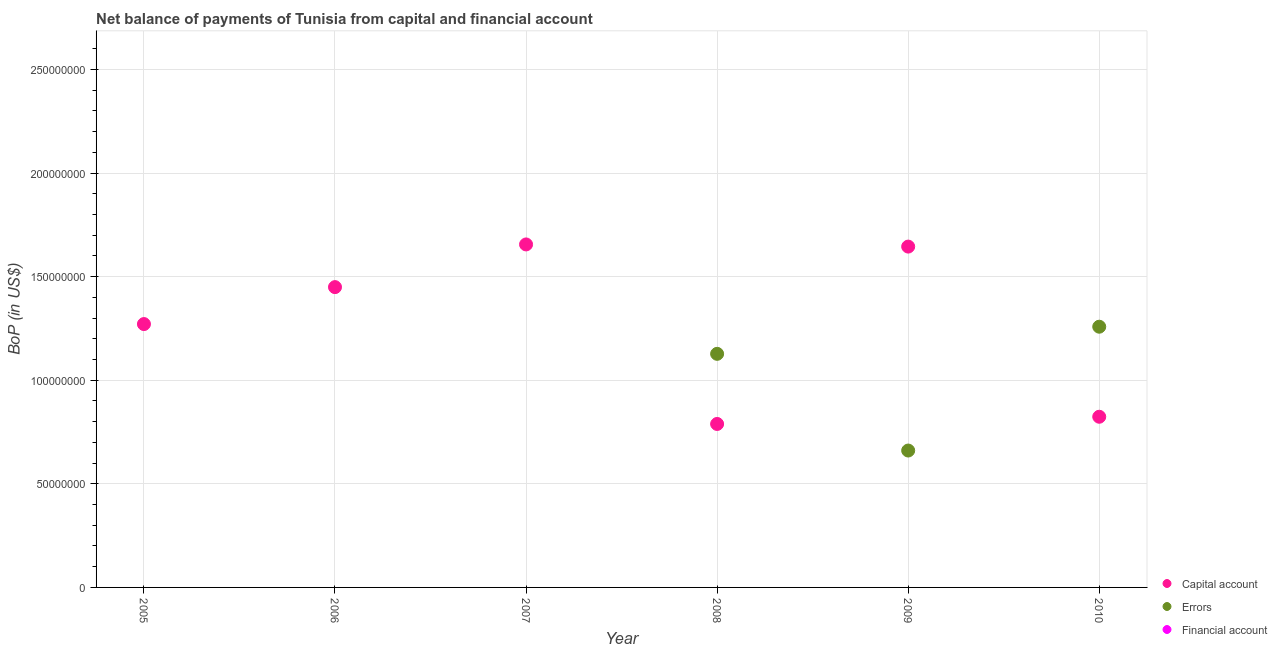What is the amount of net capital account in 2009?
Keep it short and to the point. 1.64e+08. Across all years, what is the maximum amount of errors?
Give a very brief answer. 1.26e+08. Across all years, what is the minimum amount of net capital account?
Ensure brevity in your answer.  7.89e+07. In which year was the amount of net capital account maximum?
Ensure brevity in your answer.  2007. What is the total amount of net capital account in the graph?
Your answer should be very brief. 7.63e+08. What is the difference between the amount of net capital account in 2008 and that in 2010?
Provide a succinct answer. -3.48e+06. What is the difference between the amount of financial account in 2009 and the amount of errors in 2008?
Your answer should be very brief. -1.13e+08. In the year 2010, what is the difference between the amount of errors and amount of net capital account?
Give a very brief answer. 4.35e+07. In how many years, is the amount of errors greater than 40000000 US$?
Provide a succinct answer. 3. What is the ratio of the amount of net capital account in 2006 to that in 2010?
Keep it short and to the point. 1.76. Is the amount of net capital account in 2005 less than that in 2010?
Make the answer very short. No. What is the difference between the highest and the second highest amount of net capital account?
Your response must be concise. 1.04e+06. What is the difference between the highest and the lowest amount of errors?
Your answer should be compact. 1.26e+08. Is the sum of the amount of net capital account in 2007 and 2009 greater than the maximum amount of errors across all years?
Make the answer very short. Yes. Is it the case that in every year, the sum of the amount of net capital account and amount of errors is greater than the amount of financial account?
Make the answer very short. Yes. Is the amount of net capital account strictly greater than the amount of errors over the years?
Keep it short and to the point. No. How many dotlines are there?
Ensure brevity in your answer.  2. Are the values on the major ticks of Y-axis written in scientific E-notation?
Your answer should be compact. No. Where does the legend appear in the graph?
Provide a succinct answer. Bottom right. What is the title of the graph?
Give a very brief answer. Net balance of payments of Tunisia from capital and financial account. Does "Ages 0-14" appear as one of the legend labels in the graph?
Give a very brief answer. No. What is the label or title of the X-axis?
Your answer should be compact. Year. What is the label or title of the Y-axis?
Your answer should be very brief. BoP (in US$). What is the BoP (in US$) of Capital account in 2005?
Make the answer very short. 1.27e+08. What is the BoP (in US$) of Financial account in 2005?
Provide a succinct answer. 0. What is the BoP (in US$) in Capital account in 2006?
Offer a terse response. 1.45e+08. What is the BoP (in US$) of Financial account in 2006?
Keep it short and to the point. 0. What is the BoP (in US$) in Capital account in 2007?
Provide a short and direct response. 1.66e+08. What is the BoP (in US$) of Errors in 2007?
Offer a very short reply. 0. What is the BoP (in US$) in Capital account in 2008?
Give a very brief answer. 7.89e+07. What is the BoP (in US$) in Errors in 2008?
Ensure brevity in your answer.  1.13e+08. What is the BoP (in US$) of Financial account in 2008?
Offer a very short reply. 0. What is the BoP (in US$) of Capital account in 2009?
Give a very brief answer. 1.64e+08. What is the BoP (in US$) of Errors in 2009?
Offer a very short reply. 6.61e+07. What is the BoP (in US$) in Financial account in 2009?
Offer a terse response. 0. What is the BoP (in US$) in Capital account in 2010?
Your response must be concise. 8.24e+07. What is the BoP (in US$) in Errors in 2010?
Keep it short and to the point. 1.26e+08. What is the BoP (in US$) of Financial account in 2010?
Give a very brief answer. 0. Across all years, what is the maximum BoP (in US$) of Capital account?
Give a very brief answer. 1.66e+08. Across all years, what is the maximum BoP (in US$) of Errors?
Your answer should be compact. 1.26e+08. Across all years, what is the minimum BoP (in US$) of Capital account?
Your response must be concise. 7.89e+07. What is the total BoP (in US$) in Capital account in the graph?
Keep it short and to the point. 7.63e+08. What is the total BoP (in US$) of Errors in the graph?
Offer a terse response. 3.05e+08. What is the difference between the BoP (in US$) in Capital account in 2005 and that in 2006?
Make the answer very short. -1.78e+07. What is the difference between the BoP (in US$) in Capital account in 2005 and that in 2007?
Ensure brevity in your answer.  -3.84e+07. What is the difference between the BoP (in US$) of Capital account in 2005 and that in 2008?
Ensure brevity in your answer.  4.82e+07. What is the difference between the BoP (in US$) in Capital account in 2005 and that in 2009?
Ensure brevity in your answer.  -3.74e+07. What is the difference between the BoP (in US$) in Capital account in 2005 and that in 2010?
Your answer should be compact. 4.47e+07. What is the difference between the BoP (in US$) of Capital account in 2006 and that in 2007?
Offer a terse response. -2.06e+07. What is the difference between the BoP (in US$) of Capital account in 2006 and that in 2008?
Give a very brief answer. 6.60e+07. What is the difference between the BoP (in US$) of Capital account in 2006 and that in 2009?
Your response must be concise. -1.96e+07. What is the difference between the BoP (in US$) of Capital account in 2006 and that in 2010?
Ensure brevity in your answer.  6.26e+07. What is the difference between the BoP (in US$) of Capital account in 2007 and that in 2008?
Provide a succinct answer. 8.66e+07. What is the difference between the BoP (in US$) of Capital account in 2007 and that in 2009?
Provide a succinct answer. 1.04e+06. What is the difference between the BoP (in US$) of Capital account in 2007 and that in 2010?
Provide a succinct answer. 8.32e+07. What is the difference between the BoP (in US$) in Capital account in 2008 and that in 2009?
Offer a very short reply. -8.56e+07. What is the difference between the BoP (in US$) in Errors in 2008 and that in 2009?
Make the answer very short. 4.67e+07. What is the difference between the BoP (in US$) of Capital account in 2008 and that in 2010?
Your answer should be very brief. -3.48e+06. What is the difference between the BoP (in US$) of Errors in 2008 and that in 2010?
Give a very brief answer. -1.31e+07. What is the difference between the BoP (in US$) of Capital account in 2009 and that in 2010?
Provide a short and direct response. 8.21e+07. What is the difference between the BoP (in US$) in Errors in 2009 and that in 2010?
Your answer should be very brief. -5.98e+07. What is the difference between the BoP (in US$) in Capital account in 2005 and the BoP (in US$) in Errors in 2008?
Your answer should be compact. 1.44e+07. What is the difference between the BoP (in US$) of Capital account in 2005 and the BoP (in US$) of Errors in 2009?
Your answer should be very brief. 6.10e+07. What is the difference between the BoP (in US$) of Capital account in 2005 and the BoP (in US$) of Errors in 2010?
Ensure brevity in your answer.  1.28e+06. What is the difference between the BoP (in US$) in Capital account in 2006 and the BoP (in US$) in Errors in 2008?
Offer a terse response. 3.22e+07. What is the difference between the BoP (in US$) in Capital account in 2006 and the BoP (in US$) in Errors in 2009?
Give a very brief answer. 7.89e+07. What is the difference between the BoP (in US$) of Capital account in 2006 and the BoP (in US$) of Errors in 2010?
Keep it short and to the point. 1.91e+07. What is the difference between the BoP (in US$) in Capital account in 2007 and the BoP (in US$) in Errors in 2008?
Your response must be concise. 5.28e+07. What is the difference between the BoP (in US$) of Capital account in 2007 and the BoP (in US$) of Errors in 2009?
Give a very brief answer. 9.95e+07. What is the difference between the BoP (in US$) in Capital account in 2007 and the BoP (in US$) in Errors in 2010?
Your answer should be very brief. 3.97e+07. What is the difference between the BoP (in US$) in Capital account in 2008 and the BoP (in US$) in Errors in 2009?
Provide a short and direct response. 1.28e+07. What is the difference between the BoP (in US$) of Capital account in 2008 and the BoP (in US$) of Errors in 2010?
Provide a succinct answer. -4.69e+07. What is the difference between the BoP (in US$) of Capital account in 2009 and the BoP (in US$) of Errors in 2010?
Keep it short and to the point. 3.87e+07. What is the average BoP (in US$) of Capital account per year?
Make the answer very short. 1.27e+08. What is the average BoP (in US$) in Errors per year?
Provide a succinct answer. 5.08e+07. In the year 2008, what is the difference between the BoP (in US$) in Capital account and BoP (in US$) in Errors?
Provide a succinct answer. -3.38e+07. In the year 2009, what is the difference between the BoP (in US$) in Capital account and BoP (in US$) in Errors?
Provide a short and direct response. 9.84e+07. In the year 2010, what is the difference between the BoP (in US$) in Capital account and BoP (in US$) in Errors?
Your answer should be compact. -4.35e+07. What is the ratio of the BoP (in US$) in Capital account in 2005 to that in 2006?
Offer a very short reply. 0.88. What is the ratio of the BoP (in US$) of Capital account in 2005 to that in 2007?
Offer a very short reply. 0.77. What is the ratio of the BoP (in US$) in Capital account in 2005 to that in 2008?
Give a very brief answer. 1.61. What is the ratio of the BoP (in US$) of Capital account in 2005 to that in 2009?
Keep it short and to the point. 0.77. What is the ratio of the BoP (in US$) in Capital account in 2005 to that in 2010?
Offer a very short reply. 1.54. What is the ratio of the BoP (in US$) of Capital account in 2006 to that in 2007?
Offer a very short reply. 0.88. What is the ratio of the BoP (in US$) of Capital account in 2006 to that in 2008?
Your response must be concise. 1.84. What is the ratio of the BoP (in US$) of Capital account in 2006 to that in 2009?
Provide a short and direct response. 0.88. What is the ratio of the BoP (in US$) in Capital account in 2006 to that in 2010?
Provide a succinct answer. 1.76. What is the ratio of the BoP (in US$) in Capital account in 2007 to that in 2008?
Your answer should be compact. 2.1. What is the ratio of the BoP (in US$) of Capital account in 2007 to that in 2009?
Ensure brevity in your answer.  1.01. What is the ratio of the BoP (in US$) of Capital account in 2007 to that in 2010?
Your answer should be compact. 2.01. What is the ratio of the BoP (in US$) of Capital account in 2008 to that in 2009?
Provide a succinct answer. 0.48. What is the ratio of the BoP (in US$) of Errors in 2008 to that in 2009?
Give a very brief answer. 1.71. What is the ratio of the BoP (in US$) in Capital account in 2008 to that in 2010?
Your answer should be very brief. 0.96. What is the ratio of the BoP (in US$) of Errors in 2008 to that in 2010?
Offer a terse response. 0.9. What is the ratio of the BoP (in US$) in Capital account in 2009 to that in 2010?
Offer a terse response. 2. What is the ratio of the BoP (in US$) of Errors in 2009 to that in 2010?
Make the answer very short. 0.53. What is the difference between the highest and the second highest BoP (in US$) of Capital account?
Give a very brief answer. 1.04e+06. What is the difference between the highest and the second highest BoP (in US$) of Errors?
Your answer should be compact. 1.31e+07. What is the difference between the highest and the lowest BoP (in US$) of Capital account?
Ensure brevity in your answer.  8.66e+07. What is the difference between the highest and the lowest BoP (in US$) of Errors?
Offer a very short reply. 1.26e+08. 